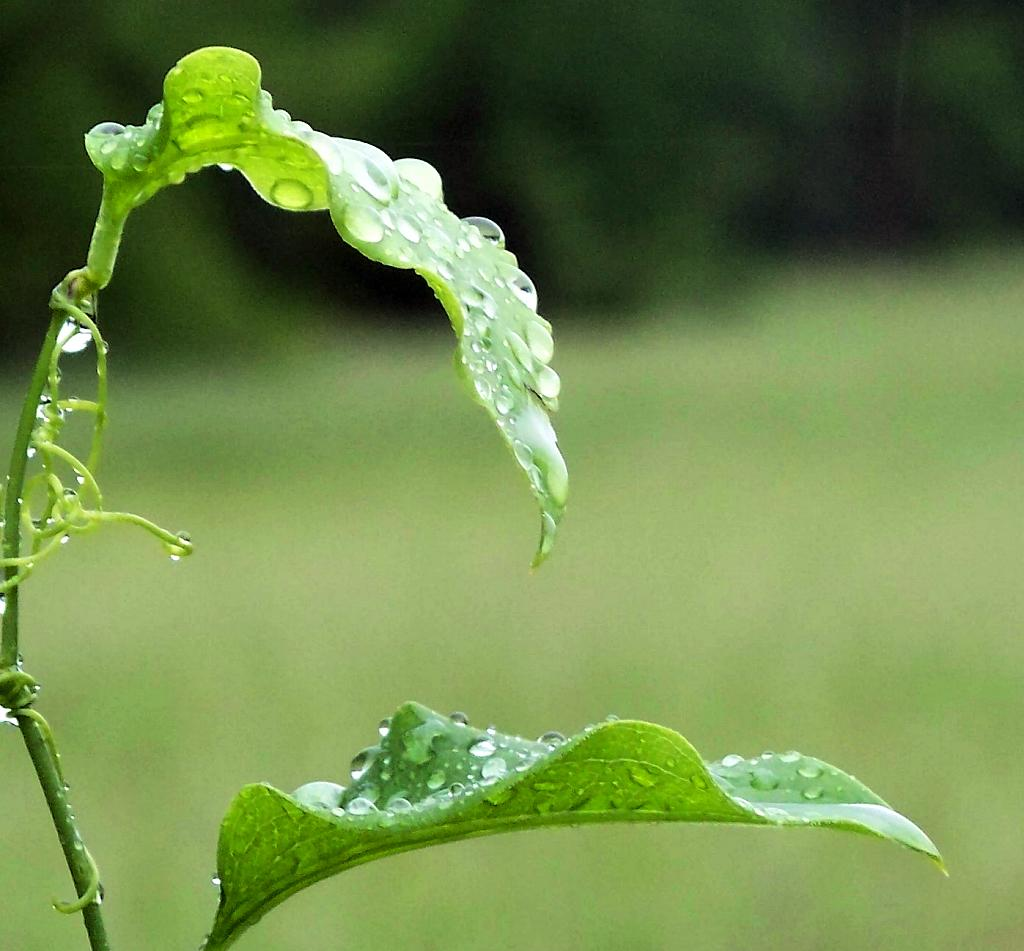What is the main subject of the picture? The main subject of the picture is a plant. How many leaves does the plant have? The plant has two leaves. What can be seen on the leaves of the plant? There are water droplets on the plant. What can be seen in the background of the picture? There is greenery visible in the background, but it is not clearly visible. What type of feeling is the plant expressing in the image? Plants do not express feelings, so this question cannot be answered definitively from the image. How many additional leaves are being discussed in the image? There is no discussion of leaves in the image, only the observation of two leaves on the plant. 